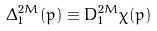Convert formula to latex. <formula><loc_0><loc_0><loc_500><loc_500>\Delta ^ { 2 M } _ { 1 } ( p ) \equiv D ^ { 2 M } _ { 1 } \chi ( p )</formula> 